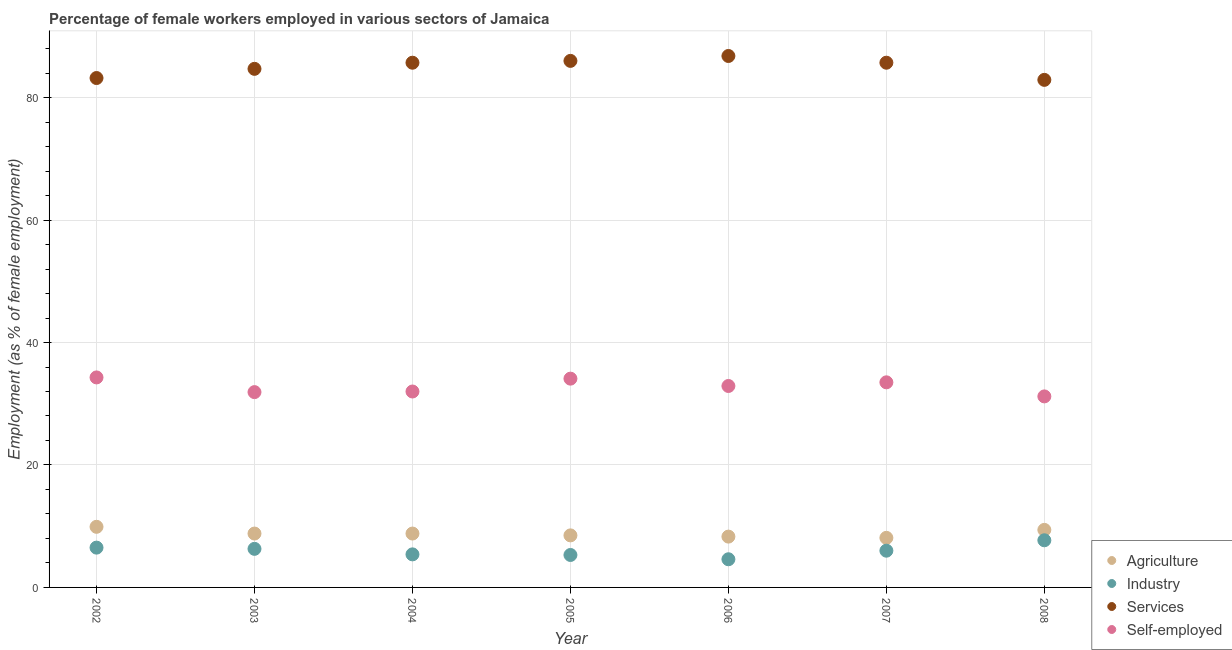What is the percentage of female workers in industry in 2008?
Ensure brevity in your answer.  7.7. Across all years, what is the maximum percentage of self employed female workers?
Give a very brief answer. 34.3. Across all years, what is the minimum percentage of female workers in agriculture?
Ensure brevity in your answer.  8.1. In which year was the percentage of self employed female workers maximum?
Your response must be concise. 2002. What is the total percentage of female workers in industry in the graph?
Keep it short and to the point. 41.8. What is the difference between the percentage of female workers in services in 2004 and that in 2007?
Ensure brevity in your answer.  0. What is the difference between the percentage of female workers in services in 2005 and the percentage of self employed female workers in 2004?
Offer a very short reply. 54. What is the average percentage of self employed female workers per year?
Provide a short and direct response. 32.84. In the year 2002, what is the difference between the percentage of female workers in agriculture and percentage of female workers in services?
Offer a very short reply. -73.3. In how many years, is the percentage of self employed female workers greater than 84 %?
Your answer should be compact. 0. What is the ratio of the percentage of female workers in agriculture in 2003 to that in 2008?
Offer a terse response. 0.94. Is the percentage of self employed female workers in 2005 less than that in 2007?
Your answer should be very brief. No. Is the difference between the percentage of female workers in services in 2002 and 2008 greater than the difference between the percentage of self employed female workers in 2002 and 2008?
Your response must be concise. No. What is the difference between the highest and the lowest percentage of female workers in services?
Your response must be concise. 3.9. Is it the case that in every year, the sum of the percentage of female workers in agriculture and percentage of female workers in industry is greater than the percentage of female workers in services?
Give a very brief answer. No. Does the percentage of female workers in services monotonically increase over the years?
Your answer should be very brief. No. How many dotlines are there?
Give a very brief answer. 4. How many years are there in the graph?
Make the answer very short. 7. What is the difference between two consecutive major ticks on the Y-axis?
Keep it short and to the point. 20. Are the values on the major ticks of Y-axis written in scientific E-notation?
Give a very brief answer. No. Does the graph contain any zero values?
Your answer should be compact. No. What is the title of the graph?
Provide a succinct answer. Percentage of female workers employed in various sectors of Jamaica. Does "Periodicity assessment" appear as one of the legend labels in the graph?
Give a very brief answer. No. What is the label or title of the X-axis?
Your answer should be very brief. Year. What is the label or title of the Y-axis?
Keep it short and to the point. Employment (as % of female employment). What is the Employment (as % of female employment) of Agriculture in 2002?
Make the answer very short. 9.9. What is the Employment (as % of female employment) of Industry in 2002?
Your answer should be very brief. 6.5. What is the Employment (as % of female employment) in Services in 2002?
Keep it short and to the point. 83.2. What is the Employment (as % of female employment) in Self-employed in 2002?
Ensure brevity in your answer.  34.3. What is the Employment (as % of female employment) of Agriculture in 2003?
Your response must be concise. 8.8. What is the Employment (as % of female employment) of Industry in 2003?
Your answer should be very brief. 6.3. What is the Employment (as % of female employment) in Services in 2003?
Make the answer very short. 84.7. What is the Employment (as % of female employment) in Self-employed in 2003?
Give a very brief answer. 31.9. What is the Employment (as % of female employment) in Agriculture in 2004?
Offer a terse response. 8.8. What is the Employment (as % of female employment) of Industry in 2004?
Your response must be concise. 5.4. What is the Employment (as % of female employment) of Services in 2004?
Ensure brevity in your answer.  85.7. What is the Employment (as % of female employment) of Self-employed in 2004?
Provide a succinct answer. 32. What is the Employment (as % of female employment) in Agriculture in 2005?
Make the answer very short. 8.5. What is the Employment (as % of female employment) of Industry in 2005?
Your answer should be compact. 5.3. What is the Employment (as % of female employment) in Services in 2005?
Give a very brief answer. 86. What is the Employment (as % of female employment) of Self-employed in 2005?
Offer a very short reply. 34.1. What is the Employment (as % of female employment) in Agriculture in 2006?
Make the answer very short. 8.3. What is the Employment (as % of female employment) of Industry in 2006?
Keep it short and to the point. 4.6. What is the Employment (as % of female employment) in Services in 2006?
Offer a very short reply. 86.8. What is the Employment (as % of female employment) of Self-employed in 2006?
Your answer should be very brief. 32.9. What is the Employment (as % of female employment) of Agriculture in 2007?
Provide a short and direct response. 8.1. What is the Employment (as % of female employment) in Industry in 2007?
Offer a terse response. 6. What is the Employment (as % of female employment) in Services in 2007?
Make the answer very short. 85.7. What is the Employment (as % of female employment) in Self-employed in 2007?
Your answer should be very brief. 33.5. What is the Employment (as % of female employment) of Agriculture in 2008?
Offer a terse response. 9.4. What is the Employment (as % of female employment) in Industry in 2008?
Keep it short and to the point. 7.7. What is the Employment (as % of female employment) in Services in 2008?
Your response must be concise. 82.9. What is the Employment (as % of female employment) of Self-employed in 2008?
Offer a terse response. 31.2. Across all years, what is the maximum Employment (as % of female employment) of Agriculture?
Provide a succinct answer. 9.9. Across all years, what is the maximum Employment (as % of female employment) of Industry?
Offer a very short reply. 7.7. Across all years, what is the maximum Employment (as % of female employment) in Services?
Give a very brief answer. 86.8. Across all years, what is the maximum Employment (as % of female employment) of Self-employed?
Offer a terse response. 34.3. Across all years, what is the minimum Employment (as % of female employment) of Agriculture?
Provide a short and direct response. 8.1. Across all years, what is the minimum Employment (as % of female employment) of Industry?
Your response must be concise. 4.6. Across all years, what is the minimum Employment (as % of female employment) of Services?
Offer a very short reply. 82.9. Across all years, what is the minimum Employment (as % of female employment) of Self-employed?
Make the answer very short. 31.2. What is the total Employment (as % of female employment) of Agriculture in the graph?
Give a very brief answer. 61.8. What is the total Employment (as % of female employment) in Industry in the graph?
Your answer should be very brief. 41.8. What is the total Employment (as % of female employment) in Services in the graph?
Provide a short and direct response. 595. What is the total Employment (as % of female employment) of Self-employed in the graph?
Keep it short and to the point. 229.9. What is the difference between the Employment (as % of female employment) in Industry in 2002 and that in 2003?
Your response must be concise. 0.2. What is the difference between the Employment (as % of female employment) of Services in 2002 and that in 2003?
Keep it short and to the point. -1.5. What is the difference between the Employment (as % of female employment) of Services in 2002 and that in 2004?
Offer a very short reply. -2.5. What is the difference between the Employment (as % of female employment) of Self-employed in 2002 and that in 2004?
Your response must be concise. 2.3. What is the difference between the Employment (as % of female employment) of Agriculture in 2002 and that in 2005?
Your answer should be compact. 1.4. What is the difference between the Employment (as % of female employment) in Industry in 2002 and that in 2005?
Your answer should be very brief. 1.2. What is the difference between the Employment (as % of female employment) in Self-employed in 2002 and that in 2005?
Your answer should be very brief. 0.2. What is the difference between the Employment (as % of female employment) in Agriculture in 2002 and that in 2006?
Give a very brief answer. 1.6. What is the difference between the Employment (as % of female employment) in Industry in 2002 and that in 2006?
Keep it short and to the point. 1.9. What is the difference between the Employment (as % of female employment) in Self-employed in 2002 and that in 2006?
Provide a short and direct response. 1.4. What is the difference between the Employment (as % of female employment) of Agriculture in 2002 and that in 2007?
Keep it short and to the point. 1.8. What is the difference between the Employment (as % of female employment) of Services in 2002 and that in 2007?
Keep it short and to the point. -2.5. What is the difference between the Employment (as % of female employment) in Agriculture in 2002 and that in 2008?
Offer a terse response. 0.5. What is the difference between the Employment (as % of female employment) of Agriculture in 2003 and that in 2004?
Keep it short and to the point. 0. What is the difference between the Employment (as % of female employment) of Agriculture in 2003 and that in 2005?
Make the answer very short. 0.3. What is the difference between the Employment (as % of female employment) in Industry in 2003 and that in 2005?
Your answer should be very brief. 1. What is the difference between the Employment (as % of female employment) of Services in 2003 and that in 2005?
Your response must be concise. -1.3. What is the difference between the Employment (as % of female employment) of Industry in 2003 and that in 2006?
Your answer should be compact. 1.7. What is the difference between the Employment (as % of female employment) of Self-employed in 2003 and that in 2006?
Provide a short and direct response. -1. What is the difference between the Employment (as % of female employment) in Agriculture in 2003 and that in 2007?
Give a very brief answer. 0.7. What is the difference between the Employment (as % of female employment) of Industry in 2003 and that in 2007?
Your answer should be very brief. 0.3. What is the difference between the Employment (as % of female employment) in Services in 2003 and that in 2007?
Ensure brevity in your answer.  -1. What is the difference between the Employment (as % of female employment) in Self-employed in 2003 and that in 2007?
Your answer should be very brief. -1.6. What is the difference between the Employment (as % of female employment) of Industry in 2003 and that in 2008?
Give a very brief answer. -1.4. What is the difference between the Employment (as % of female employment) of Services in 2003 and that in 2008?
Provide a succinct answer. 1.8. What is the difference between the Employment (as % of female employment) in Agriculture in 2004 and that in 2005?
Keep it short and to the point. 0.3. What is the difference between the Employment (as % of female employment) of Industry in 2004 and that in 2005?
Give a very brief answer. 0.1. What is the difference between the Employment (as % of female employment) of Industry in 2004 and that in 2007?
Ensure brevity in your answer.  -0.6. What is the difference between the Employment (as % of female employment) of Services in 2004 and that in 2007?
Your answer should be very brief. 0. What is the difference between the Employment (as % of female employment) in Self-employed in 2004 and that in 2007?
Your answer should be compact. -1.5. What is the difference between the Employment (as % of female employment) of Agriculture in 2004 and that in 2008?
Ensure brevity in your answer.  -0.6. What is the difference between the Employment (as % of female employment) of Industry in 2004 and that in 2008?
Make the answer very short. -2.3. What is the difference between the Employment (as % of female employment) in Agriculture in 2005 and that in 2007?
Your answer should be very brief. 0.4. What is the difference between the Employment (as % of female employment) in Services in 2005 and that in 2007?
Your answer should be compact. 0.3. What is the difference between the Employment (as % of female employment) of Self-employed in 2005 and that in 2007?
Offer a terse response. 0.6. What is the difference between the Employment (as % of female employment) in Agriculture in 2005 and that in 2008?
Offer a terse response. -0.9. What is the difference between the Employment (as % of female employment) in Industry in 2006 and that in 2007?
Provide a succinct answer. -1.4. What is the difference between the Employment (as % of female employment) in Industry in 2006 and that in 2008?
Ensure brevity in your answer.  -3.1. What is the difference between the Employment (as % of female employment) in Services in 2007 and that in 2008?
Give a very brief answer. 2.8. What is the difference between the Employment (as % of female employment) in Agriculture in 2002 and the Employment (as % of female employment) in Services in 2003?
Offer a very short reply. -74.8. What is the difference between the Employment (as % of female employment) of Agriculture in 2002 and the Employment (as % of female employment) of Self-employed in 2003?
Your answer should be very brief. -22. What is the difference between the Employment (as % of female employment) in Industry in 2002 and the Employment (as % of female employment) in Services in 2003?
Provide a succinct answer. -78.2. What is the difference between the Employment (as % of female employment) of Industry in 2002 and the Employment (as % of female employment) of Self-employed in 2003?
Keep it short and to the point. -25.4. What is the difference between the Employment (as % of female employment) of Services in 2002 and the Employment (as % of female employment) of Self-employed in 2003?
Give a very brief answer. 51.3. What is the difference between the Employment (as % of female employment) of Agriculture in 2002 and the Employment (as % of female employment) of Industry in 2004?
Provide a short and direct response. 4.5. What is the difference between the Employment (as % of female employment) of Agriculture in 2002 and the Employment (as % of female employment) of Services in 2004?
Your response must be concise. -75.8. What is the difference between the Employment (as % of female employment) in Agriculture in 2002 and the Employment (as % of female employment) in Self-employed in 2004?
Ensure brevity in your answer.  -22.1. What is the difference between the Employment (as % of female employment) in Industry in 2002 and the Employment (as % of female employment) in Services in 2004?
Keep it short and to the point. -79.2. What is the difference between the Employment (as % of female employment) of Industry in 2002 and the Employment (as % of female employment) of Self-employed in 2004?
Give a very brief answer. -25.5. What is the difference between the Employment (as % of female employment) in Services in 2002 and the Employment (as % of female employment) in Self-employed in 2004?
Make the answer very short. 51.2. What is the difference between the Employment (as % of female employment) in Agriculture in 2002 and the Employment (as % of female employment) in Industry in 2005?
Make the answer very short. 4.6. What is the difference between the Employment (as % of female employment) in Agriculture in 2002 and the Employment (as % of female employment) in Services in 2005?
Make the answer very short. -76.1. What is the difference between the Employment (as % of female employment) in Agriculture in 2002 and the Employment (as % of female employment) in Self-employed in 2005?
Offer a very short reply. -24.2. What is the difference between the Employment (as % of female employment) of Industry in 2002 and the Employment (as % of female employment) of Services in 2005?
Provide a succinct answer. -79.5. What is the difference between the Employment (as % of female employment) of Industry in 2002 and the Employment (as % of female employment) of Self-employed in 2005?
Make the answer very short. -27.6. What is the difference between the Employment (as % of female employment) in Services in 2002 and the Employment (as % of female employment) in Self-employed in 2005?
Ensure brevity in your answer.  49.1. What is the difference between the Employment (as % of female employment) in Agriculture in 2002 and the Employment (as % of female employment) in Industry in 2006?
Your response must be concise. 5.3. What is the difference between the Employment (as % of female employment) in Agriculture in 2002 and the Employment (as % of female employment) in Services in 2006?
Provide a short and direct response. -76.9. What is the difference between the Employment (as % of female employment) of Industry in 2002 and the Employment (as % of female employment) of Services in 2006?
Provide a succinct answer. -80.3. What is the difference between the Employment (as % of female employment) in Industry in 2002 and the Employment (as % of female employment) in Self-employed in 2006?
Your response must be concise. -26.4. What is the difference between the Employment (as % of female employment) of Services in 2002 and the Employment (as % of female employment) of Self-employed in 2006?
Offer a terse response. 50.3. What is the difference between the Employment (as % of female employment) in Agriculture in 2002 and the Employment (as % of female employment) in Industry in 2007?
Your answer should be compact. 3.9. What is the difference between the Employment (as % of female employment) in Agriculture in 2002 and the Employment (as % of female employment) in Services in 2007?
Provide a short and direct response. -75.8. What is the difference between the Employment (as % of female employment) of Agriculture in 2002 and the Employment (as % of female employment) of Self-employed in 2007?
Ensure brevity in your answer.  -23.6. What is the difference between the Employment (as % of female employment) of Industry in 2002 and the Employment (as % of female employment) of Services in 2007?
Give a very brief answer. -79.2. What is the difference between the Employment (as % of female employment) in Services in 2002 and the Employment (as % of female employment) in Self-employed in 2007?
Offer a terse response. 49.7. What is the difference between the Employment (as % of female employment) in Agriculture in 2002 and the Employment (as % of female employment) in Industry in 2008?
Your response must be concise. 2.2. What is the difference between the Employment (as % of female employment) in Agriculture in 2002 and the Employment (as % of female employment) in Services in 2008?
Give a very brief answer. -73. What is the difference between the Employment (as % of female employment) of Agriculture in 2002 and the Employment (as % of female employment) of Self-employed in 2008?
Keep it short and to the point. -21.3. What is the difference between the Employment (as % of female employment) in Industry in 2002 and the Employment (as % of female employment) in Services in 2008?
Ensure brevity in your answer.  -76.4. What is the difference between the Employment (as % of female employment) of Industry in 2002 and the Employment (as % of female employment) of Self-employed in 2008?
Ensure brevity in your answer.  -24.7. What is the difference between the Employment (as % of female employment) in Agriculture in 2003 and the Employment (as % of female employment) in Industry in 2004?
Provide a succinct answer. 3.4. What is the difference between the Employment (as % of female employment) of Agriculture in 2003 and the Employment (as % of female employment) of Services in 2004?
Keep it short and to the point. -76.9. What is the difference between the Employment (as % of female employment) in Agriculture in 2003 and the Employment (as % of female employment) in Self-employed in 2004?
Your response must be concise. -23.2. What is the difference between the Employment (as % of female employment) in Industry in 2003 and the Employment (as % of female employment) in Services in 2004?
Make the answer very short. -79.4. What is the difference between the Employment (as % of female employment) in Industry in 2003 and the Employment (as % of female employment) in Self-employed in 2004?
Your response must be concise. -25.7. What is the difference between the Employment (as % of female employment) in Services in 2003 and the Employment (as % of female employment) in Self-employed in 2004?
Ensure brevity in your answer.  52.7. What is the difference between the Employment (as % of female employment) in Agriculture in 2003 and the Employment (as % of female employment) in Services in 2005?
Offer a very short reply. -77.2. What is the difference between the Employment (as % of female employment) in Agriculture in 2003 and the Employment (as % of female employment) in Self-employed in 2005?
Provide a succinct answer. -25.3. What is the difference between the Employment (as % of female employment) of Industry in 2003 and the Employment (as % of female employment) of Services in 2005?
Your answer should be compact. -79.7. What is the difference between the Employment (as % of female employment) in Industry in 2003 and the Employment (as % of female employment) in Self-employed in 2005?
Keep it short and to the point. -27.8. What is the difference between the Employment (as % of female employment) in Services in 2003 and the Employment (as % of female employment) in Self-employed in 2005?
Provide a succinct answer. 50.6. What is the difference between the Employment (as % of female employment) in Agriculture in 2003 and the Employment (as % of female employment) in Industry in 2006?
Offer a very short reply. 4.2. What is the difference between the Employment (as % of female employment) in Agriculture in 2003 and the Employment (as % of female employment) in Services in 2006?
Your answer should be very brief. -78. What is the difference between the Employment (as % of female employment) of Agriculture in 2003 and the Employment (as % of female employment) of Self-employed in 2006?
Give a very brief answer. -24.1. What is the difference between the Employment (as % of female employment) of Industry in 2003 and the Employment (as % of female employment) of Services in 2006?
Keep it short and to the point. -80.5. What is the difference between the Employment (as % of female employment) in Industry in 2003 and the Employment (as % of female employment) in Self-employed in 2006?
Your answer should be compact. -26.6. What is the difference between the Employment (as % of female employment) of Services in 2003 and the Employment (as % of female employment) of Self-employed in 2006?
Offer a very short reply. 51.8. What is the difference between the Employment (as % of female employment) in Agriculture in 2003 and the Employment (as % of female employment) in Services in 2007?
Offer a terse response. -76.9. What is the difference between the Employment (as % of female employment) in Agriculture in 2003 and the Employment (as % of female employment) in Self-employed in 2007?
Ensure brevity in your answer.  -24.7. What is the difference between the Employment (as % of female employment) of Industry in 2003 and the Employment (as % of female employment) of Services in 2007?
Your answer should be compact. -79.4. What is the difference between the Employment (as % of female employment) of Industry in 2003 and the Employment (as % of female employment) of Self-employed in 2007?
Your answer should be very brief. -27.2. What is the difference between the Employment (as % of female employment) in Services in 2003 and the Employment (as % of female employment) in Self-employed in 2007?
Give a very brief answer. 51.2. What is the difference between the Employment (as % of female employment) in Agriculture in 2003 and the Employment (as % of female employment) in Services in 2008?
Your answer should be very brief. -74.1. What is the difference between the Employment (as % of female employment) in Agriculture in 2003 and the Employment (as % of female employment) in Self-employed in 2008?
Give a very brief answer. -22.4. What is the difference between the Employment (as % of female employment) in Industry in 2003 and the Employment (as % of female employment) in Services in 2008?
Provide a short and direct response. -76.6. What is the difference between the Employment (as % of female employment) in Industry in 2003 and the Employment (as % of female employment) in Self-employed in 2008?
Your answer should be very brief. -24.9. What is the difference between the Employment (as % of female employment) of Services in 2003 and the Employment (as % of female employment) of Self-employed in 2008?
Your answer should be very brief. 53.5. What is the difference between the Employment (as % of female employment) of Agriculture in 2004 and the Employment (as % of female employment) of Services in 2005?
Offer a very short reply. -77.2. What is the difference between the Employment (as % of female employment) of Agriculture in 2004 and the Employment (as % of female employment) of Self-employed in 2005?
Make the answer very short. -25.3. What is the difference between the Employment (as % of female employment) in Industry in 2004 and the Employment (as % of female employment) in Services in 2005?
Ensure brevity in your answer.  -80.6. What is the difference between the Employment (as % of female employment) of Industry in 2004 and the Employment (as % of female employment) of Self-employed in 2005?
Provide a short and direct response. -28.7. What is the difference between the Employment (as % of female employment) in Services in 2004 and the Employment (as % of female employment) in Self-employed in 2005?
Offer a terse response. 51.6. What is the difference between the Employment (as % of female employment) in Agriculture in 2004 and the Employment (as % of female employment) in Industry in 2006?
Provide a short and direct response. 4.2. What is the difference between the Employment (as % of female employment) of Agriculture in 2004 and the Employment (as % of female employment) of Services in 2006?
Offer a terse response. -78. What is the difference between the Employment (as % of female employment) in Agriculture in 2004 and the Employment (as % of female employment) in Self-employed in 2006?
Your answer should be compact. -24.1. What is the difference between the Employment (as % of female employment) of Industry in 2004 and the Employment (as % of female employment) of Services in 2006?
Make the answer very short. -81.4. What is the difference between the Employment (as % of female employment) in Industry in 2004 and the Employment (as % of female employment) in Self-employed in 2006?
Your answer should be compact. -27.5. What is the difference between the Employment (as % of female employment) in Services in 2004 and the Employment (as % of female employment) in Self-employed in 2006?
Your answer should be very brief. 52.8. What is the difference between the Employment (as % of female employment) in Agriculture in 2004 and the Employment (as % of female employment) in Industry in 2007?
Offer a very short reply. 2.8. What is the difference between the Employment (as % of female employment) in Agriculture in 2004 and the Employment (as % of female employment) in Services in 2007?
Keep it short and to the point. -76.9. What is the difference between the Employment (as % of female employment) of Agriculture in 2004 and the Employment (as % of female employment) of Self-employed in 2007?
Give a very brief answer. -24.7. What is the difference between the Employment (as % of female employment) in Industry in 2004 and the Employment (as % of female employment) in Services in 2007?
Provide a succinct answer. -80.3. What is the difference between the Employment (as % of female employment) in Industry in 2004 and the Employment (as % of female employment) in Self-employed in 2007?
Your answer should be very brief. -28.1. What is the difference between the Employment (as % of female employment) of Services in 2004 and the Employment (as % of female employment) of Self-employed in 2007?
Offer a terse response. 52.2. What is the difference between the Employment (as % of female employment) of Agriculture in 2004 and the Employment (as % of female employment) of Services in 2008?
Offer a very short reply. -74.1. What is the difference between the Employment (as % of female employment) in Agriculture in 2004 and the Employment (as % of female employment) in Self-employed in 2008?
Provide a succinct answer. -22.4. What is the difference between the Employment (as % of female employment) in Industry in 2004 and the Employment (as % of female employment) in Services in 2008?
Your answer should be compact. -77.5. What is the difference between the Employment (as % of female employment) in Industry in 2004 and the Employment (as % of female employment) in Self-employed in 2008?
Offer a terse response. -25.8. What is the difference between the Employment (as % of female employment) of Services in 2004 and the Employment (as % of female employment) of Self-employed in 2008?
Give a very brief answer. 54.5. What is the difference between the Employment (as % of female employment) in Agriculture in 2005 and the Employment (as % of female employment) in Industry in 2006?
Your answer should be very brief. 3.9. What is the difference between the Employment (as % of female employment) in Agriculture in 2005 and the Employment (as % of female employment) in Services in 2006?
Your answer should be very brief. -78.3. What is the difference between the Employment (as % of female employment) of Agriculture in 2005 and the Employment (as % of female employment) of Self-employed in 2006?
Provide a succinct answer. -24.4. What is the difference between the Employment (as % of female employment) of Industry in 2005 and the Employment (as % of female employment) of Services in 2006?
Provide a succinct answer. -81.5. What is the difference between the Employment (as % of female employment) in Industry in 2005 and the Employment (as % of female employment) in Self-employed in 2006?
Your answer should be very brief. -27.6. What is the difference between the Employment (as % of female employment) in Services in 2005 and the Employment (as % of female employment) in Self-employed in 2006?
Provide a short and direct response. 53.1. What is the difference between the Employment (as % of female employment) in Agriculture in 2005 and the Employment (as % of female employment) in Industry in 2007?
Make the answer very short. 2.5. What is the difference between the Employment (as % of female employment) of Agriculture in 2005 and the Employment (as % of female employment) of Services in 2007?
Make the answer very short. -77.2. What is the difference between the Employment (as % of female employment) in Agriculture in 2005 and the Employment (as % of female employment) in Self-employed in 2007?
Offer a very short reply. -25. What is the difference between the Employment (as % of female employment) in Industry in 2005 and the Employment (as % of female employment) in Services in 2007?
Offer a very short reply. -80.4. What is the difference between the Employment (as % of female employment) in Industry in 2005 and the Employment (as % of female employment) in Self-employed in 2007?
Provide a succinct answer. -28.2. What is the difference between the Employment (as % of female employment) of Services in 2005 and the Employment (as % of female employment) of Self-employed in 2007?
Ensure brevity in your answer.  52.5. What is the difference between the Employment (as % of female employment) of Agriculture in 2005 and the Employment (as % of female employment) of Industry in 2008?
Offer a very short reply. 0.8. What is the difference between the Employment (as % of female employment) of Agriculture in 2005 and the Employment (as % of female employment) of Services in 2008?
Provide a short and direct response. -74.4. What is the difference between the Employment (as % of female employment) in Agriculture in 2005 and the Employment (as % of female employment) in Self-employed in 2008?
Ensure brevity in your answer.  -22.7. What is the difference between the Employment (as % of female employment) in Industry in 2005 and the Employment (as % of female employment) in Services in 2008?
Ensure brevity in your answer.  -77.6. What is the difference between the Employment (as % of female employment) in Industry in 2005 and the Employment (as % of female employment) in Self-employed in 2008?
Provide a short and direct response. -25.9. What is the difference between the Employment (as % of female employment) in Services in 2005 and the Employment (as % of female employment) in Self-employed in 2008?
Your response must be concise. 54.8. What is the difference between the Employment (as % of female employment) in Agriculture in 2006 and the Employment (as % of female employment) in Services in 2007?
Provide a succinct answer. -77.4. What is the difference between the Employment (as % of female employment) in Agriculture in 2006 and the Employment (as % of female employment) in Self-employed in 2007?
Ensure brevity in your answer.  -25.2. What is the difference between the Employment (as % of female employment) in Industry in 2006 and the Employment (as % of female employment) in Services in 2007?
Provide a short and direct response. -81.1. What is the difference between the Employment (as % of female employment) in Industry in 2006 and the Employment (as % of female employment) in Self-employed in 2007?
Offer a terse response. -28.9. What is the difference between the Employment (as % of female employment) in Services in 2006 and the Employment (as % of female employment) in Self-employed in 2007?
Provide a succinct answer. 53.3. What is the difference between the Employment (as % of female employment) of Agriculture in 2006 and the Employment (as % of female employment) of Industry in 2008?
Ensure brevity in your answer.  0.6. What is the difference between the Employment (as % of female employment) of Agriculture in 2006 and the Employment (as % of female employment) of Services in 2008?
Make the answer very short. -74.6. What is the difference between the Employment (as % of female employment) of Agriculture in 2006 and the Employment (as % of female employment) of Self-employed in 2008?
Your answer should be very brief. -22.9. What is the difference between the Employment (as % of female employment) of Industry in 2006 and the Employment (as % of female employment) of Services in 2008?
Your answer should be very brief. -78.3. What is the difference between the Employment (as % of female employment) in Industry in 2006 and the Employment (as % of female employment) in Self-employed in 2008?
Give a very brief answer. -26.6. What is the difference between the Employment (as % of female employment) of Services in 2006 and the Employment (as % of female employment) of Self-employed in 2008?
Your answer should be compact. 55.6. What is the difference between the Employment (as % of female employment) of Agriculture in 2007 and the Employment (as % of female employment) of Services in 2008?
Your response must be concise. -74.8. What is the difference between the Employment (as % of female employment) of Agriculture in 2007 and the Employment (as % of female employment) of Self-employed in 2008?
Provide a short and direct response. -23.1. What is the difference between the Employment (as % of female employment) in Industry in 2007 and the Employment (as % of female employment) in Services in 2008?
Give a very brief answer. -76.9. What is the difference between the Employment (as % of female employment) in Industry in 2007 and the Employment (as % of female employment) in Self-employed in 2008?
Offer a very short reply. -25.2. What is the difference between the Employment (as % of female employment) of Services in 2007 and the Employment (as % of female employment) of Self-employed in 2008?
Keep it short and to the point. 54.5. What is the average Employment (as % of female employment) in Agriculture per year?
Provide a succinct answer. 8.83. What is the average Employment (as % of female employment) of Industry per year?
Offer a terse response. 5.97. What is the average Employment (as % of female employment) in Services per year?
Provide a short and direct response. 85. What is the average Employment (as % of female employment) in Self-employed per year?
Your answer should be compact. 32.84. In the year 2002, what is the difference between the Employment (as % of female employment) of Agriculture and Employment (as % of female employment) of Industry?
Your response must be concise. 3.4. In the year 2002, what is the difference between the Employment (as % of female employment) of Agriculture and Employment (as % of female employment) of Services?
Give a very brief answer. -73.3. In the year 2002, what is the difference between the Employment (as % of female employment) in Agriculture and Employment (as % of female employment) in Self-employed?
Ensure brevity in your answer.  -24.4. In the year 2002, what is the difference between the Employment (as % of female employment) of Industry and Employment (as % of female employment) of Services?
Keep it short and to the point. -76.7. In the year 2002, what is the difference between the Employment (as % of female employment) in Industry and Employment (as % of female employment) in Self-employed?
Your answer should be compact. -27.8. In the year 2002, what is the difference between the Employment (as % of female employment) of Services and Employment (as % of female employment) of Self-employed?
Your answer should be compact. 48.9. In the year 2003, what is the difference between the Employment (as % of female employment) of Agriculture and Employment (as % of female employment) of Services?
Your response must be concise. -75.9. In the year 2003, what is the difference between the Employment (as % of female employment) of Agriculture and Employment (as % of female employment) of Self-employed?
Your response must be concise. -23.1. In the year 2003, what is the difference between the Employment (as % of female employment) in Industry and Employment (as % of female employment) in Services?
Ensure brevity in your answer.  -78.4. In the year 2003, what is the difference between the Employment (as % of female employment) in Industry and Employment (as % of female employment) in Self-employed?
Ensure brevity in your answer.  -25.6. In the year 2003, what is the difference between the Employment (as % of female employment) of Services and Employment (as % of female employment) of Self-employed?
Offer a very short reply. 52.8. In the year 2004, what is the difference between the Employment (as % of female employment) of Agriculture and Employment (as % of female employment) of Industry?
Your answer should be very brief. 3.4. In the year 2004, what is the difference between the Employment (as % of female employment) of Agriculture and Employment (as % of female employment) of Services?
Your response must be concise. -76.9. In the year 2004, what is the difference between the Employment (as % of female employment) of Agriculture and Employment (as % of female employment) of Self-employed?
Keep it short and to the point. -23.2. In the year 2004, what is the difference between the Employment (as % of female employment) in Industry and Employment (as % of female employment) in Services?
Your answer should be very brief. -80.3. In the year 2004, what is the difference between the Employment (as % of female employment) of Industry and Employment (as % of female employment) of Self-employed?
Give a very brief answer. -26.6. In the year 2004, what is the difference between the Employment (as % of female employment) of Services and Employment (as % of female employment) of Self-employed?
Make the answer very short. 53.7. In the year 2005, what is the difference between the Employment (as % of female employment) of Agriculture and Employment (as % of female employment) of Services?
Your answer should be compact. -77.5. In the year 2005, what is the difference between the Employment (as % of female employment) of Agriculture and Employment (as % of female employment) of Self-employed?
Your answer should be very brief. -25.6. In the year 2005, what is the difference between the Employment (as % of female employment) in Industry and Employment (as % of female employment) in Services?
Give a very brief answer. -80.7. In the year 2005, what is the difference between the Employment (as % of female employment) in Industry and Employment (as % of female employment) in Self-employed?
Keep it short and to the point. -28.8. In the year 2005, what is the difference between the Employment (as % of female employment) in Services and Employment (as % of female employment) in Self-employed?
Offer a terse response. 51.9. In the year 2006, what is the difference between the Employment (as % of female employment) in Agriculture and Employment (as % of female employment) in Services?
Offer a terse response. -78.5. In the year 2006, what is the difference between the Employment (as % of female employment) in Agriculture and Employment (as % of female employment) in Self-employed?
Provide a short and direct response. -24.6. In the year 2006, what is the difference between the Employment (as % of female employment) of Industry and Employment (as % of female employment) of Services?
Ensure brevity in your answer.  -82.2. In the year 2006, what is the difference between the Employment (as % of female employment) in Industry and Employment (as % of female employment) in Self-employed?
Offer a terse response. -28.3. In the year 2006, what is the difference between the Employment (as % of female employment) in Services and Employment (as % of female employment) in Self-employed?
Give a very brief answer. 53.9. In the year 2007, what is the difference between the Employment (as % of female employment) of Agriculture and Employment (as % of female employment) of Services?
Your response must be concise. -77.6. In the year 2007, what is the difference between the Employment (as % of female employment) of Agriculture and Employment (as % of female employment) of Self-employed?
Make the answer very short. -25.4. In the year 2007, what is the difference between the Employment (as % of female employment) in Industry and Employment (as % of female employment) in Services?
Your answer should be very brief. -79.7. In the year 2007, what is the difference between the Employment (as % of female employment) in Industry and Employment (as % of female employment) in Self-employed?
Your answer should be compact. -27.5. In the year 2007, what is the difference between the Employment (as % of female employment) of Services and Employment (as % of female employment) of Self-employed?
Your response must be concise. 52.2. In the year 2008, what is the difference between the Employment (as % of female employment) of Agriculture and Employment (as % of female employment) of Industry?
Offer a terse response. 1.7. In the year 2008, what is the difference between the Employment (as % of female employment) in Agriculture and Employment (as % of female employment) in Services?
Your answer should be very brief. -73.5. In the year 2008, what is the difference between the Employment (as % of female employment) in Agriculture and Employment (as % of female employment) in Self-employed?
Provide a succinct answer. -21.8. In the year 2008, what is the difference between the Employment (as % of female employment) of Industry and Employment (as % of female employment) of Services?
Offer a very short reply. -75.2. In the year 2008, what is the difference between the Employment (as % of female employment) in Industry and Employment (as % of female employment) in Self-employed?
Keep it short and to the point. -23.5. In the year 2008, what is the difference between the Employment (as % of female employment) of Services and Employment (as % of female employment) of Self-employed?
Offer a very short reply. 51.7. What is the ratio of the Employment (as % of female employment) of Industry in 2002 to that in 2003?
Give a very brief answer. 1.03. What is the ratio of the Employment (as % of female employment) of Services in 2002 to that in 2003?
Provide a succinct answer. 0.98. What is the ratio of the Employment (as % of female employment) in Self-employed in 2002 to that in 2003?
Offer a terse response. 1.08. What is the ratio of the Employment (as % of female employment) of Industry in 2002 to that in 2004?
Provide a succinct answer. 1.2. What is the ratio of the Employment (as % of female employment) in Services in 2002 to that in 2004?
Your answer should be very brief. 0.97. What is the ratio of the Employment (as % of female employment) in Self-employed in 2002 to that in 2004?
Your answer should be very brief. 1.07. What is the ratio of the Employment (as % of female employment) of Agriculture in 2002 to that in 2005?
Offer a very short reply. 1.16. What is the ratio of the Employment (as % of female employment) of Industry in 2002 to that in 2005?
Give a very brief answer. 1.23. What is the ratio of the Employment (as % of female employment) of Services in 2002 to that in 2005?
Keep it short and to the point. 0.97. What is the ratio of the Employment (as % of female employment) of Self-employed in 2002 to that in 2005?
Offer a very short reply. 1.01. What is the ratio of the Employment (as % of female employment) in Agriculture in 2002 to that in 2006?
Provide a succinct answer. 1.19. What is the ratio of the Employment (as % of female employment) in Industry in 2002 to that in 2006?
Offer a very short reply. 1.41. What is the ratio of the Employment (as % of female employment) in Services in 2002 to that in 2006?
Provide a succinct answer. 0.96. What is the ratio of the Employment (as % of female employment) in Self-employed in 2002 to that in 2006?
Give a very brief answer. 1.04. What is the ratio of the Employment (as % of female employment) of Agriculture in 2002 to that in 2007?
Your response must be concise. 1.22. What is the ratio of the Employment (as % of female employment) in Industry in 2002 to that in 2007?
Your answer should be very brief. 1.08. What is the ratio of the Employment (as % of female employment) in Services in 2002 to that in 2007?
Provide a succinct answer. 0.97. What is the ratio of the Employment (as % of female employment) in Self-employed in 2002 to that in 2007?
Keep it short and to the point. 1.02. What is the ratio of the Employment (as % of female employment) of Agriculture in 2002 to that in 2008?
Your answer should be compact. 1.05. What is the ratio of the Employment (as % of female employment) in Industry in 2002 to that in 2008?
Ensure brevity in your answer.  0.84. What is the ratio of the Employment (as % of female employment) in Services in 2002 to that in 2008?
Your answer should be very brief. 1. What is the ratio of the Employment (as % of female employment) in Self-employed in 2002 to that in 2008?
Give a very brief answer. 1.1. What is the ratio of the Employment (as % of female employment) of Agriculture in 2003 to that in 2004?
Your response must be concise. 1. What is the ratio of the Employment (as % of female employment) in Services in 2003 to that in 2004?
Provide a succinct answer. 0.99. What is the ratio of the Employment (as % of female employment) in Self-employed in 2003 to that in 2004?
Offer a terse response. 1. What is the ratio of the Employment (as % of female employment) in Agriculture in 2003 to that in 2005?
Provide a succinct answer. 1.04. What is the ratio of the Employment (as % of female employment) in Industry in 2003 to that in 2005?
Your answer should be very brief. 1.19. What is the ratio of the Employment (as % of female employment) of Services in 2003 to that in 2005?
Offer a very short reply. 0.98. What is the ratio of the Employment (as % of female employment) in Self-employed in 2003 to that in 2005?
Your answer should be compact. 0.94. What is the ratio of the Employment (as % of female employment) of Agriculture in 2003 to that in 2006?
Your response must be concise. 1.06. What is the ratio of the Employment (as % of female employment) of Industry in 2003 to that in 2006?
Your answer should be compact. 1.37. What is the ratio of the Employment (as % of female employment) in Services in 2003 to that in 2006?
Your answer should be very brief. 0.98. What is the ratio of the Employment (as % of female employment) of Self-employed in 2003 to that in 2006?
Provide a succinct answer. 0.97. What is the ratio of the Employment (as % of female employment) of Agriculture in 2003 to that in 2007?
Your answer should be very brief. 1.09. What is the ratio of the Employment (as % of female employment) of Industry in 2003 to that in 2007?
Provide a succinct answer. 1.05. What is the ratio of the Employment (as % of female employment) in Services in 2003 to that in 2007?
Give a very brief answer. 0.99. What is the ratio of the Employment (as % of female employment) of Self-employed in 2003 to that in 2007?
Keep it short and to the point. 0.95. What is the ratio of the Employment (as % of female employment) in Agriculture in 2003 to that in 2008?
Make the answer very short. 0.94. What is the ratio of the Employment (as % of female employment) of Industry in 2003 to that in 2008?
Your response must be concise. 0.82. What is the ratio of the Employment (as % of female employment) in Services in 2003 to that in 2008?
Offer a terse response. 1.02. What is the ratio of the Employment (as % of female employment) of Self-employed in 2003 to that in 2008?
Give a very brief answer. 1.02. What is the ratio of the Employment (as % of female employment) of Agriculture in 2004 to that in 2005?
Your answer should be compact. 1.04. What is the ratio of the Employment (as % of female employment) in Industry in 2004 to that in 2005?
Give a very brief answer. 1.02. What is the ratio of the Employment (as % of female employment) of Services in 2004 to that in 2005?
Provide a succinct answer. 1. What is the ratio of the Employment (as % of female employment) of Self-employed in 2004 to that in 2005?
Provide a succinct answer. 0.94. What is the ratio of the Employment (as % of female employment) in Agriculture in 2004 to that in 2006?
Provide a short and direct response. 1.06. What is the ratio of the Employment (as % of female employment) of Industry in 2004 to that in 2006?
Make the answer very short. 1.17. What is the ratio of the Employment (as % of female employment) in Services in 2004 to that in 2006?
Your response must be concise. 0.99. What is the ratio of the Employment (as % of female employment) in Self-employed in 2004 to that in 2006?
Make the answer very short. 0.97. What is the ratio of the Employment (as % of female employment) in Agriculture in 2004 to that in 2007?
Provide a succinct answer. 1.09. What is the ratio of the Employment (as % of female employment) of Self-employed in 2004 to that in 2007?
Make the answer very short. 0.96. What is the ratio of the Employment (as % of female employment) in Agriculture in 2004 to that in 2008?
Keep it short and to the point. 0.94. What is the ratio of the Employment (as % of female employment) of Industry in 2004 to that in 2008?
Provide a short and direct response. 0.7. What is the ratio of the Employment (as % of female employment) of Services in 2004 to that in 2008?
Your answer should be very brief. 1.03. What is the ratio of the Employment (as % of female employment) of Self-employed in 2004 to that in 2008?
Offer a terse response. 1.03. What is the ratio of the Employment (as % of female employment) in Agriculture in 2005 to that in 2006?
Offer a very short reply. 1.02. What is the ratio of the Employment (as % of female employment) in Industry in 2005 to that in 2006?
Make the answer very short. 1.15. What is the ratio of the Employment (as % of female employment) of Self-employed in 2005 to that in 2006?
Provide a short and direct response. 1.04. What is the ratio of the Employment (as % of female employment) of Agriculture in 2005 to that in 2007?
Your answer should be compact. 1.05. What is the ratio of the Employment (as % of female employment) in Industry in 2005 to that in 2007?
Provide a succinct answer. 0.88. What is the ratio of the Employment (as % of female employment) of Self-employed in 2005 to that in 2007?
Offer a terse response. 1.02. What is the ratio of the Employment (as % of female employment) in Agriculture in 2005 to that in 2008?
Offer a terse response. 0.9. What is the ratio of the Employment (as % of female employment) in Industry in 2005 to that in 2008?
Keep it short and to the point. 0.69. What is the ratio of the Employment (as % of female employment) in Services in 2005 to that in 2008?
Your answer should be very brief. 1.04. What is the ratio of the Employment (as % of female employment) in Self-employed in 2005 to that in 2008?
Provide a short and direct response. 1.09. What is the ratio of the Employment (as % of female employment) in Agriculture in 2006 to that in 2007?
Your response must be concise. 1.02. What is the ratio of the Employment (as % of female employment) in Industry in 2006 to that in 2007?
Your answer should be compact. 0.77. What is the ratio of the Employment (as % of female employment) of Services in 2006 to that in 2007?
Ensure brevity in your answer.  1.01. What is the ratio of the Employment (as % of female employment) of Self-employed in 2006 to that in 2007?
Give a very brief answer. 0.98. What is the ratio of the Employment (as % of female employment) of Agriculture in 2006 to that in 2008?
Provide a short and direct response. 0.88. What is the ratio of the Employment (as % of female employment) of Industry in 2006 to that in 2008?
Offer a terse response. 0.6. What is the ratio of the Employment (as % of female employment) of Services in 2006 to that in 2008?
Ensure brevity in your answer.  1.05. What is the ratio of the Employment (as % of female employment) of Self-employed in 2006 to that in 2008?
Provide a succinct answer. 1.05. What is the ratio of the Employment (as % of female employment) of Agriculture in 2007 to that in 2008?
Provide a succinct answer. 0.86. What is the ratio of the Employment (as % of female employment) of Industry in 2007 to that in 2008?
Make the answer very short. 0.78. What is the ratio of the Employment (as % of female employment) in Services in 2007 to that in 2008?
Make the answer very short. 1.03. What is the ratio of the Employment (as % of female employment) in Self-employed in 2007 to that in 2008?
Your answer should be very brief. 1.07. What is the difference between the highest and the second highest Employment (as % of female employment) of Industry?
Keep it short and to the point. 1.2. What is the difference between the highest and the second highest Employment (as % of female employment) in Self-employed?
Make the answer very short. 0.2. What is the difference between the highest and the lowest Employment (as % of female employment) of Industry?
Make the answer very short. 3.1. 